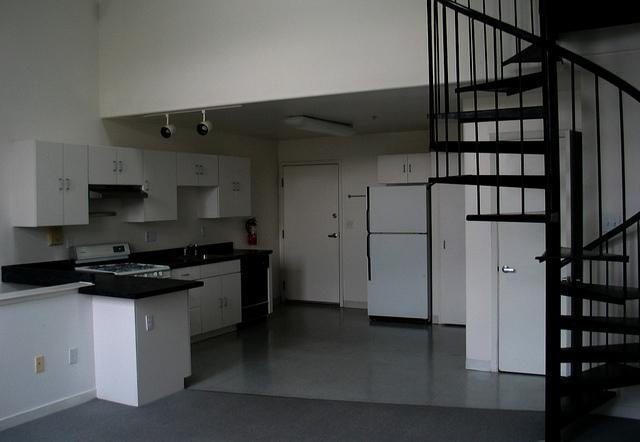How many trash cans are there?
Give a very brief answer. 0. 